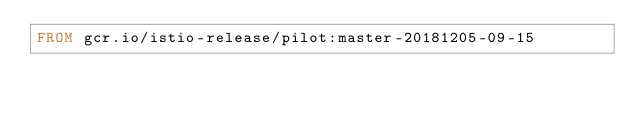Convert code to text. <code><loc_0><loc_0><loc_500><loc_500><_Dockerfile_>FROM gcr.io/istio-release/pilot:master-20181205-09-15
</code> 